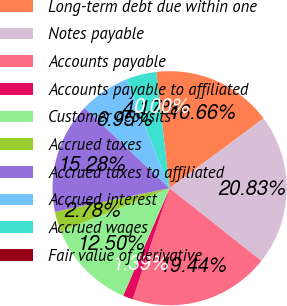<chart> <loc_0><loc_0><loc_500><loc_500><pie_chart><fcel>Long-term debt due within one<fcel>Notes payable<fcel>Accounts payable<fcel>Accounts payable to affiliated<fcel>Customer deposits<fcel>Accrued taxes<fcel>Accrued taxes to affiliated<fcel>Accrued interest<fcel>Accrued wages<fcel>Fair value of derivative<nl><fcel>16.66%<fcel>20.83%<fcel>19.44%<fcel>1.39%<fcel>12.5%<fcel>2.78%<fcel>15.28%<fcel>6.95%<fcel>4.17%<fcel>0.0%<nl></chart> 